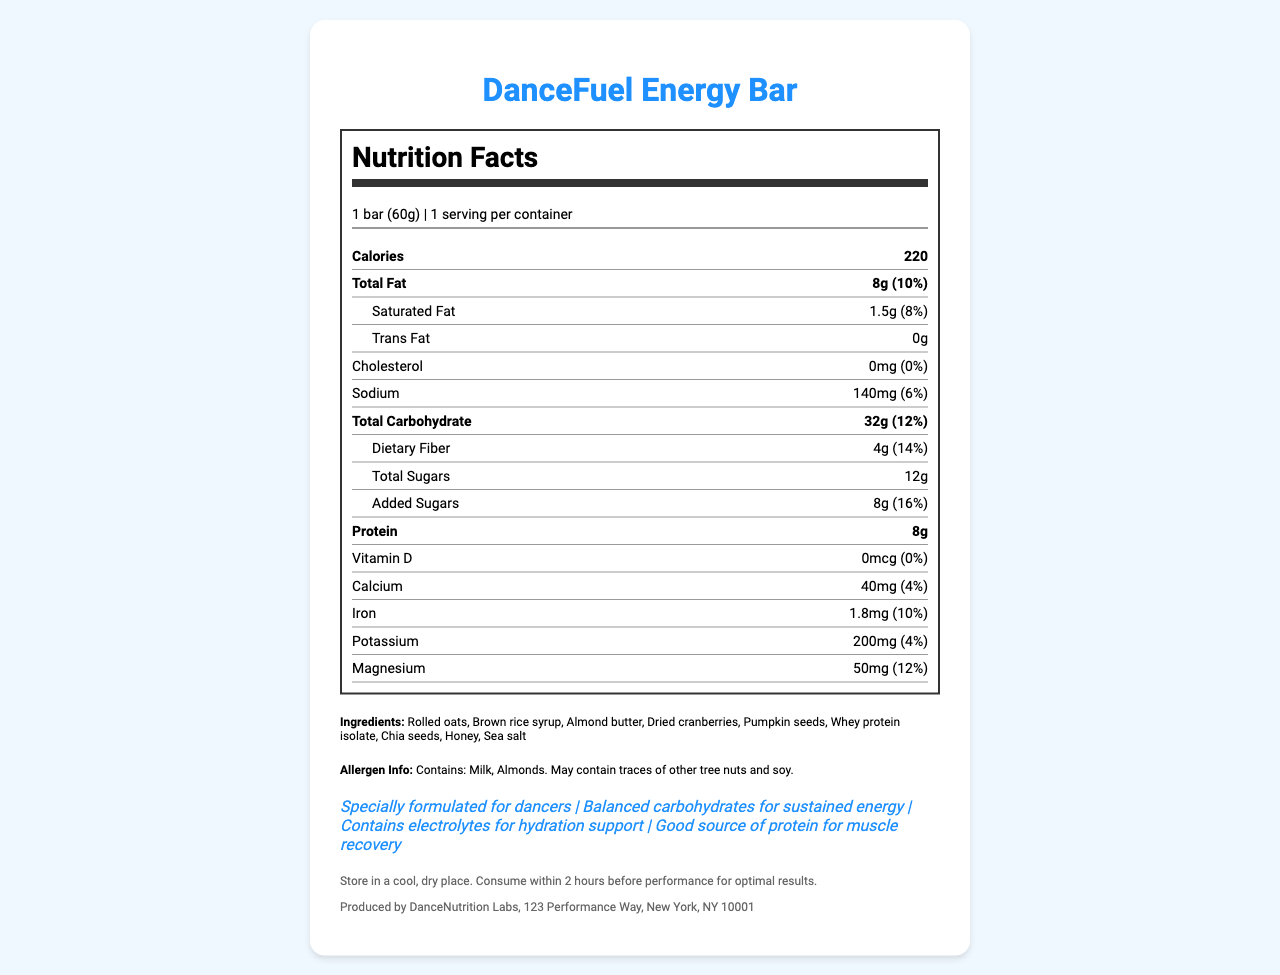what is the serving size of the DanceFuel Energy Bar? The serving size is explicitly mentioned in the document as "1 bar (60g)".
Answer: 1 bar (60g) how many calories does the DanceFuel Energy Bar contain? The document states that the energy bar contains 220 calories.
Answer: 220 what is the total fat content per serving? The total fat content per serving is listed as 8g in the nutrition facts section.
Answer: 8g how much protein does the DanceFuel Energy Bar provide? The protein content is specified as 8g per serving.
Answer: 8g which claims does the DanceFuel Energy Bar make regarding its benefits for dancers? The document lists these claims in the claim statements section.
Answer: Specially formulated for dancers, Balanced carbohydrates for sustained energy, Contains electrolytes for hydration support, Good source of protein for muscle recovery how much dietary fiber is present in one serving of the DanceFuel Energy Bar? The dietary fiber is indicated as 4g per serving in the nutrition facts.
Answer: 4g which of the following ingredients is not listed in the DanceFuel Energy Bar? A. Almond butter B. Honey C. Blueberries D. Pumpkin seeds Blueberries are not listed in the ingredient list of the bar.
Answer: C what is the percentage daily value of calcium in the DanceFuel Energy Bar? The document shows the daily value percentage for calcium as 4%.
Answer: 4% does the DanceFuel Energy Bar contain any trans fat? The document specifies that the trans fat content is 0g, indicating it contains no trans fat.
Answer: No what allergens are present in the DanceFuel Energy Bar? The allergen information section lists Milk and Almonds as allergens.
Answer: Milk, Almonds how much sodium is in a serving of the DanceFuel Energy Bar? The sodium content per serving is mentioned as 140mg.
Answer: 140mg how long before a performance should the DanceFuel Energy Bar ideally be consumed for optimal results? The storage instructions recommend consuming the bar within 2 hours before performance for optimal results.
Answer: Within 2 hours before performance which mineral does the DanceFuel Energy Bar provide the most of: calcium, iron, or magnesium? The magnesium content is 50mg with a daily value of 12%, which is higher in daily value percentage compared to calcium (4%) and iron (10%).
Answer: Magnesium can all the nutritional information be determined solely based on the document? The document provides specific details about the nutrition facts, but it does not include information for all possible nutrients.
Answer: No describe the main content and purpose of the DanceFuel Energy Bar's nutrition label document. The document comprehensively presents the nutrition facts and essential details for consumers, especially dancers, to understand the benefits and composition of the DanceFuel Energy Bar.
Answer: The document provides the nutritional information, ingredient list, allergen details, claim statements, storage instructions, and manufacturer details for the DanceFuel Energy Bar. It highlights the bar's benefits for dancers, like sustained energy release, hydration support, and muscle recovery benefits. 